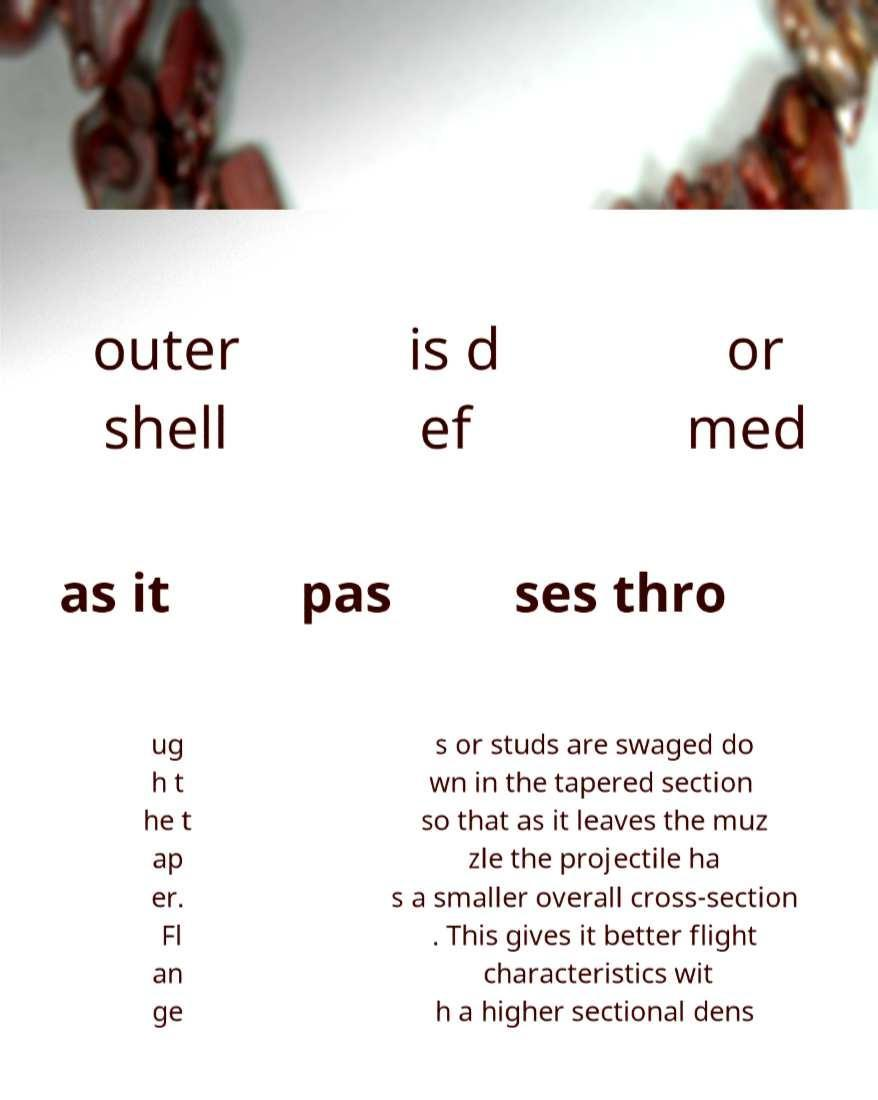Please identify and transcribe the text found in this image. outer shell is d ef or med as it pas ses thro ug h t he t ap er. Fl an ge s or studs are swaged do wn in the tapered section so that as it leaves the muz zle the projectile ha s a smaller overall cross-section . This gives it better flight characteristics wit h a higher sectional dens 